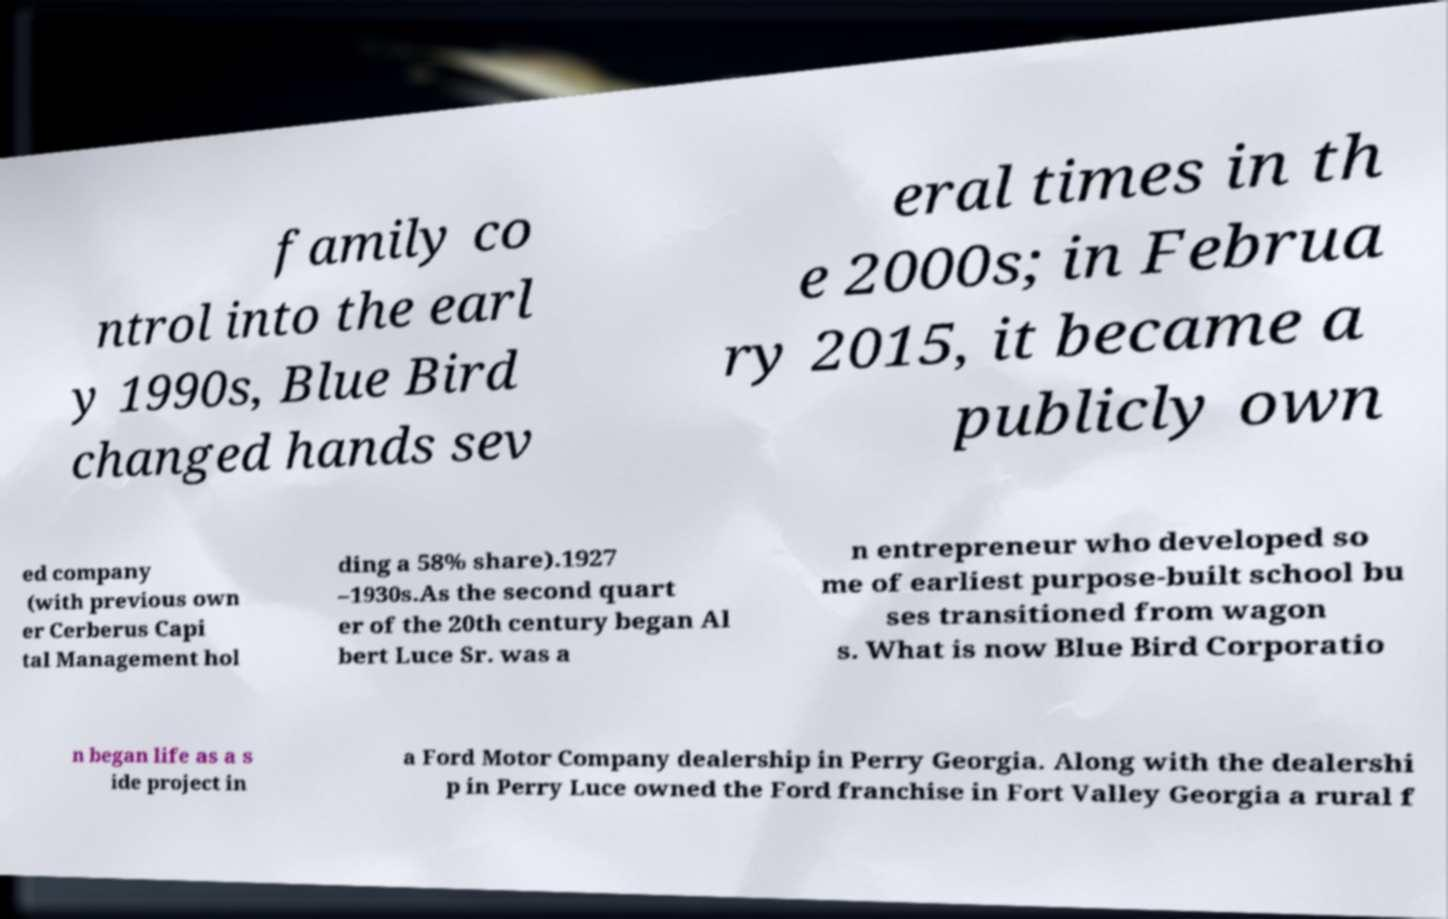Could you assist in decoding the text presented in this image and type it out clearly? family co ntrol into the earl y 1990s, Blue Bird changed hands sev eral times in th e 2000s; in Februa ry 2015, it became a publicly own ed company (with previous own er Cerberus Capi tal Management hol ding a 58% share).1927 –1930s.As the second quart er of the 20th century began Al bert Luce Sr. was a n entrepreneur who developed so me of earliest purpose-built school bu ses transitioned from wagon s. What is now Blue Bird Corporatio n began life as a s ide project in a Ford Motor Company dealership in Perry Georgia. Along with the dealershi p in Perry Luce owned the Ford franchise in Fort Valley Georgia a rural f 